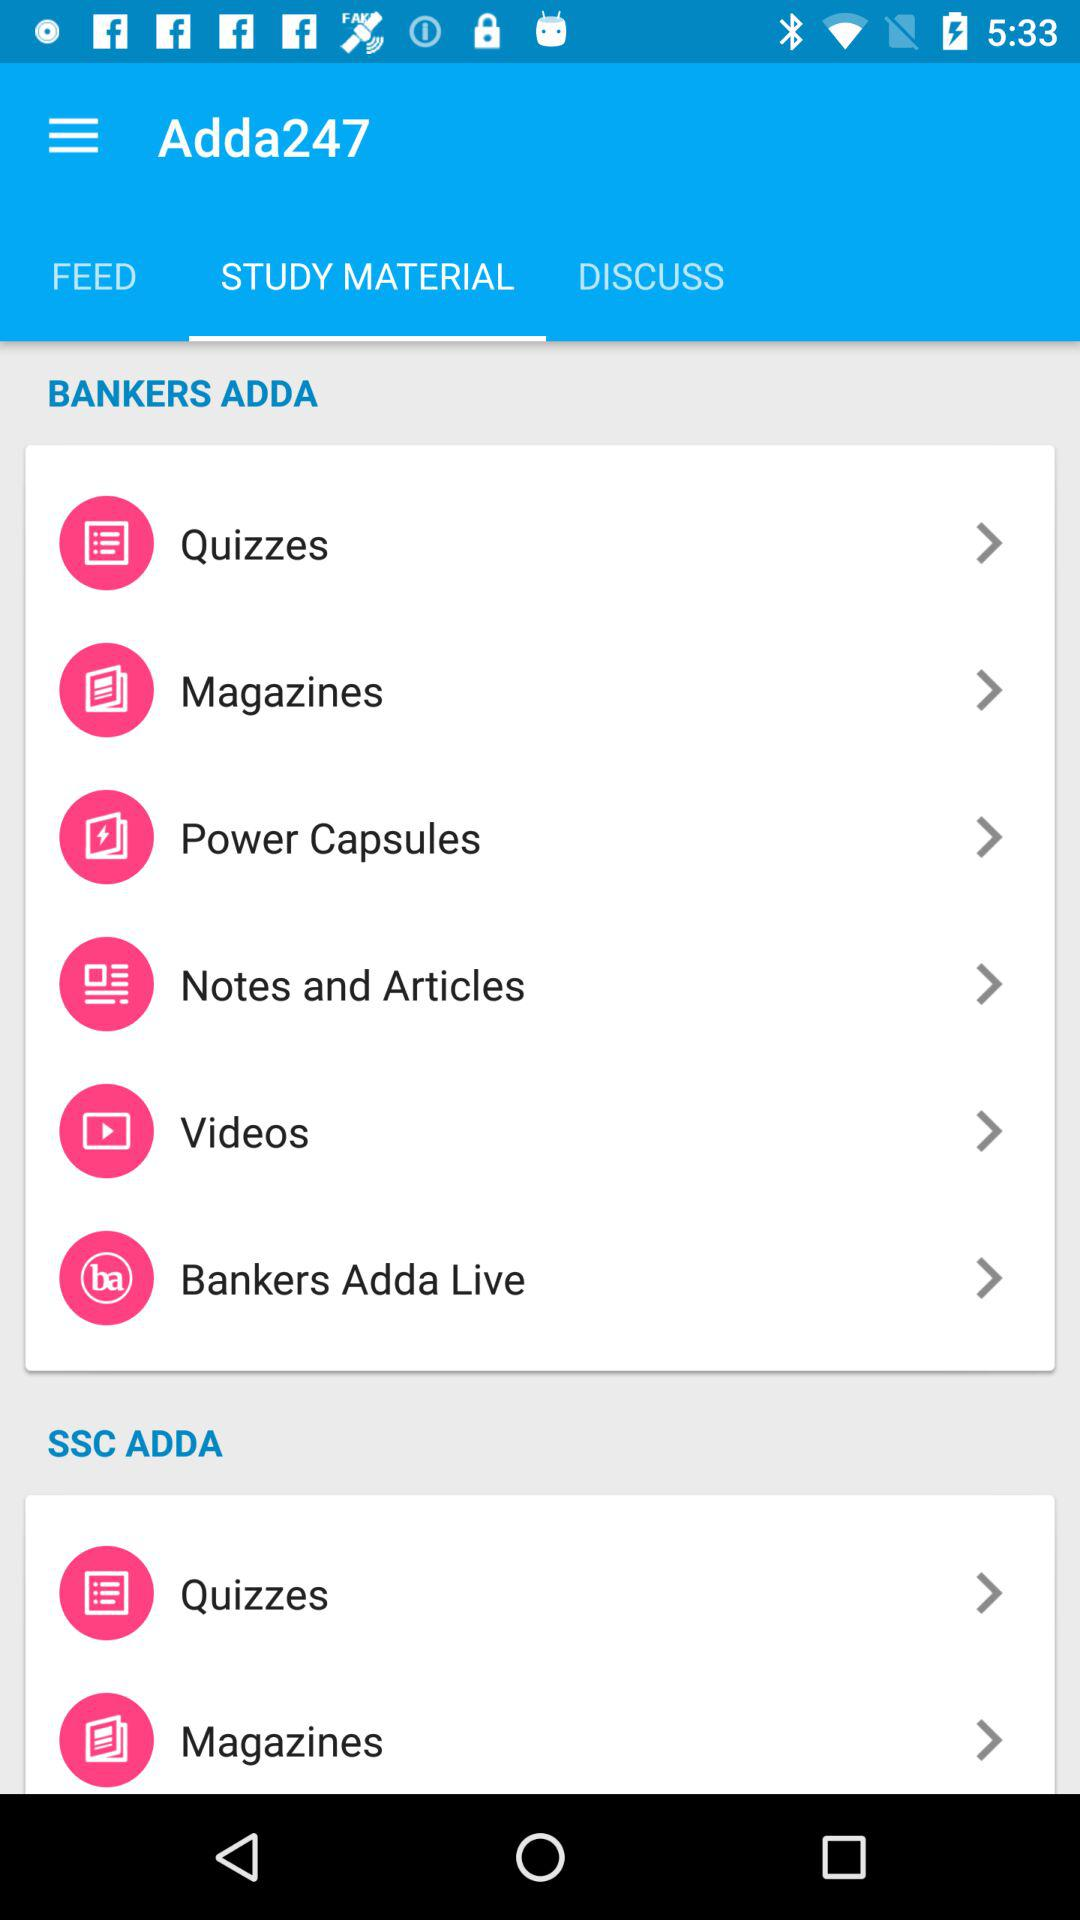Which tab is selected in Adda247? The selected tab is "STUDY MATERIAL". 